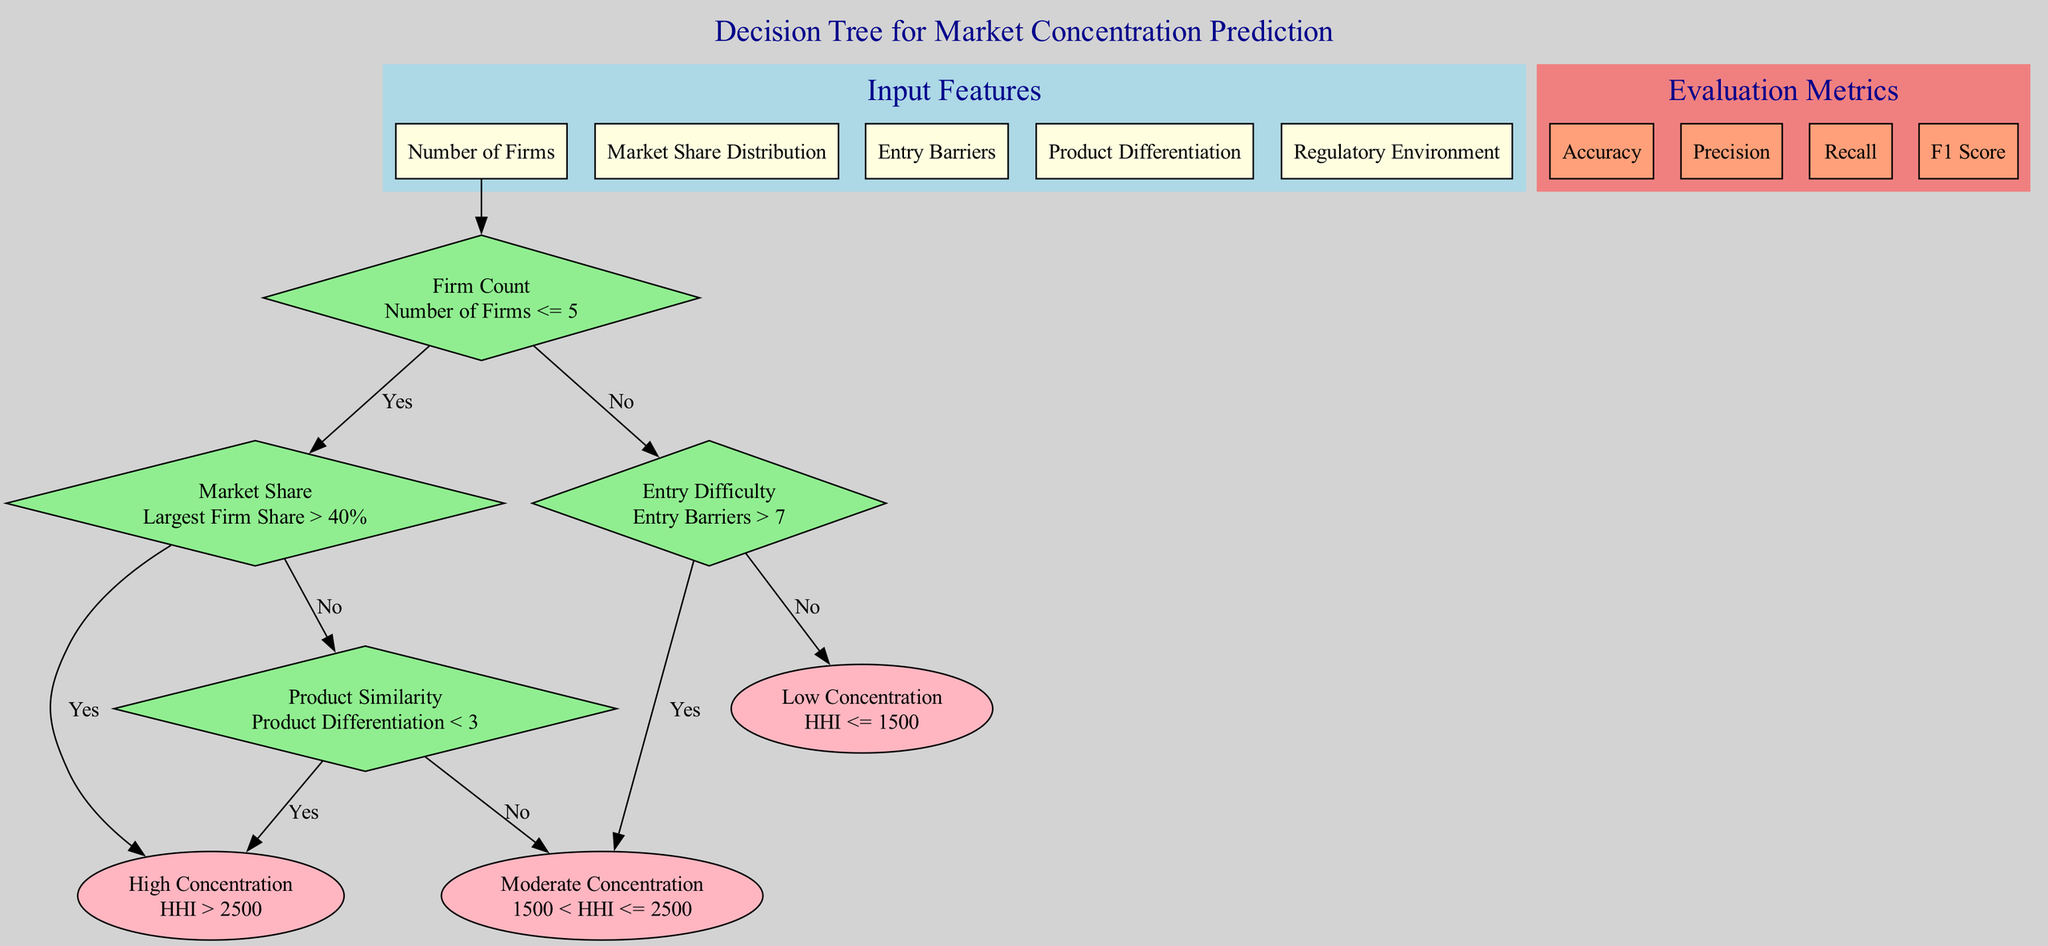What is the first input feature? The first input feature is labeled as "Number of Firms" in the input features section of the diagram.
Answer: Number of Firms How many decision nodes are present in the diagram? There are four decision nodes, as indicated in the decision nodes section of the diagram.
Answer: 4 What is the condition for the last decision node? The last decision node is "Product Similarity" with the condition "Product Differentiation < 3," which is shown as the final decision node leading to either high or moderate concentration.
Answer: Product Differentiation < 3 If the condition "Number of Firms <= 5" is true and "Largest Firm Share > 40%" is false, what will be the output? Since "Number of Firms <= 5" is true, it leads to the next decision node; then, since "Largest Firm Share > 40%" is false, it directs to "Leaf_1," indicating "Moderate Concentration."
Answer: Moderate Concentration What outputs can occur if "Entry Barriers > 7"? If "Entry Barriers > 7" is true, it leads to "Leaf_0," indicating "High Concentration," as per the flow of the decision nodes after evaluating the entry difficulties.
Answer: High Concentration Which evaluation metric is used to measure the accuracy of the model? The metrics in the evaluation section include "Accuracy," among others. Therefore, validity or performance on classification will rely on this measure to assess effectiveness.
Answer: Accuracy What is the threshold for High Concentration? The threshold for "High Concentration" is defined as "HHI > 2500" indicated in the leaf node description for high concentration output.
Answer: HHI > 2500 Which leaf node describes Low Concentration? The leaf node describing "Low Concentration" is "Leaf_2," which states "HHI <= 1500," depicted clearly in the leaf nodes section.
Answer: HHI <= 1500 If the "Product Differentiation" is equal to 2, what will happen after that condition check? Checking the "Product Differentiation" condition, if it is equal to 2, which is less than 3, it leads to "Leaf_0," indicating "High Concentration," satisfying the decision tree route outlined.
Answer: High Concentration 